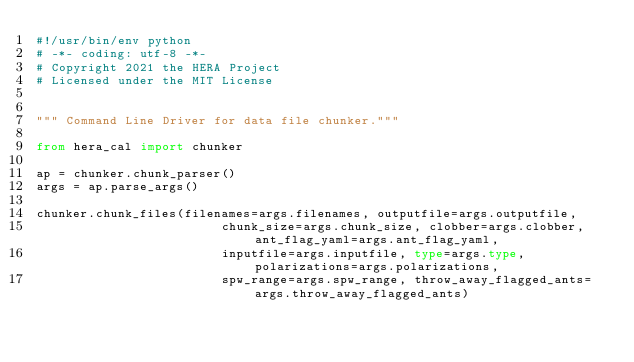<code> <loc_0><loc_0><loc_500><loc_500><_Python_>#!/usr/bin/env python
# -*- coding: utf-8 -*-
# Copyright 2021 the HERA Project
# Licensed under the MIT License


""" Command Line Driver for data file chunker."""

from hera_cal import chunker

ap = chunker.chunk_parser()
args = ap.parse_args()

chunker.chunk_files(filenames=args.filenames, outputfile=args.outputfile,
                         chunk_size=args.chunk_size, clobber=args.clobber, ant_flag_yaml=args.ant_flag_yaml,
                         inputfile=args.inputfile, type=args.type, polarizations=args.polarizations,
                         spw_range=args.spw_range, throw_away_flagged_ants=args.throw_away_flagged_ants)
</code> 